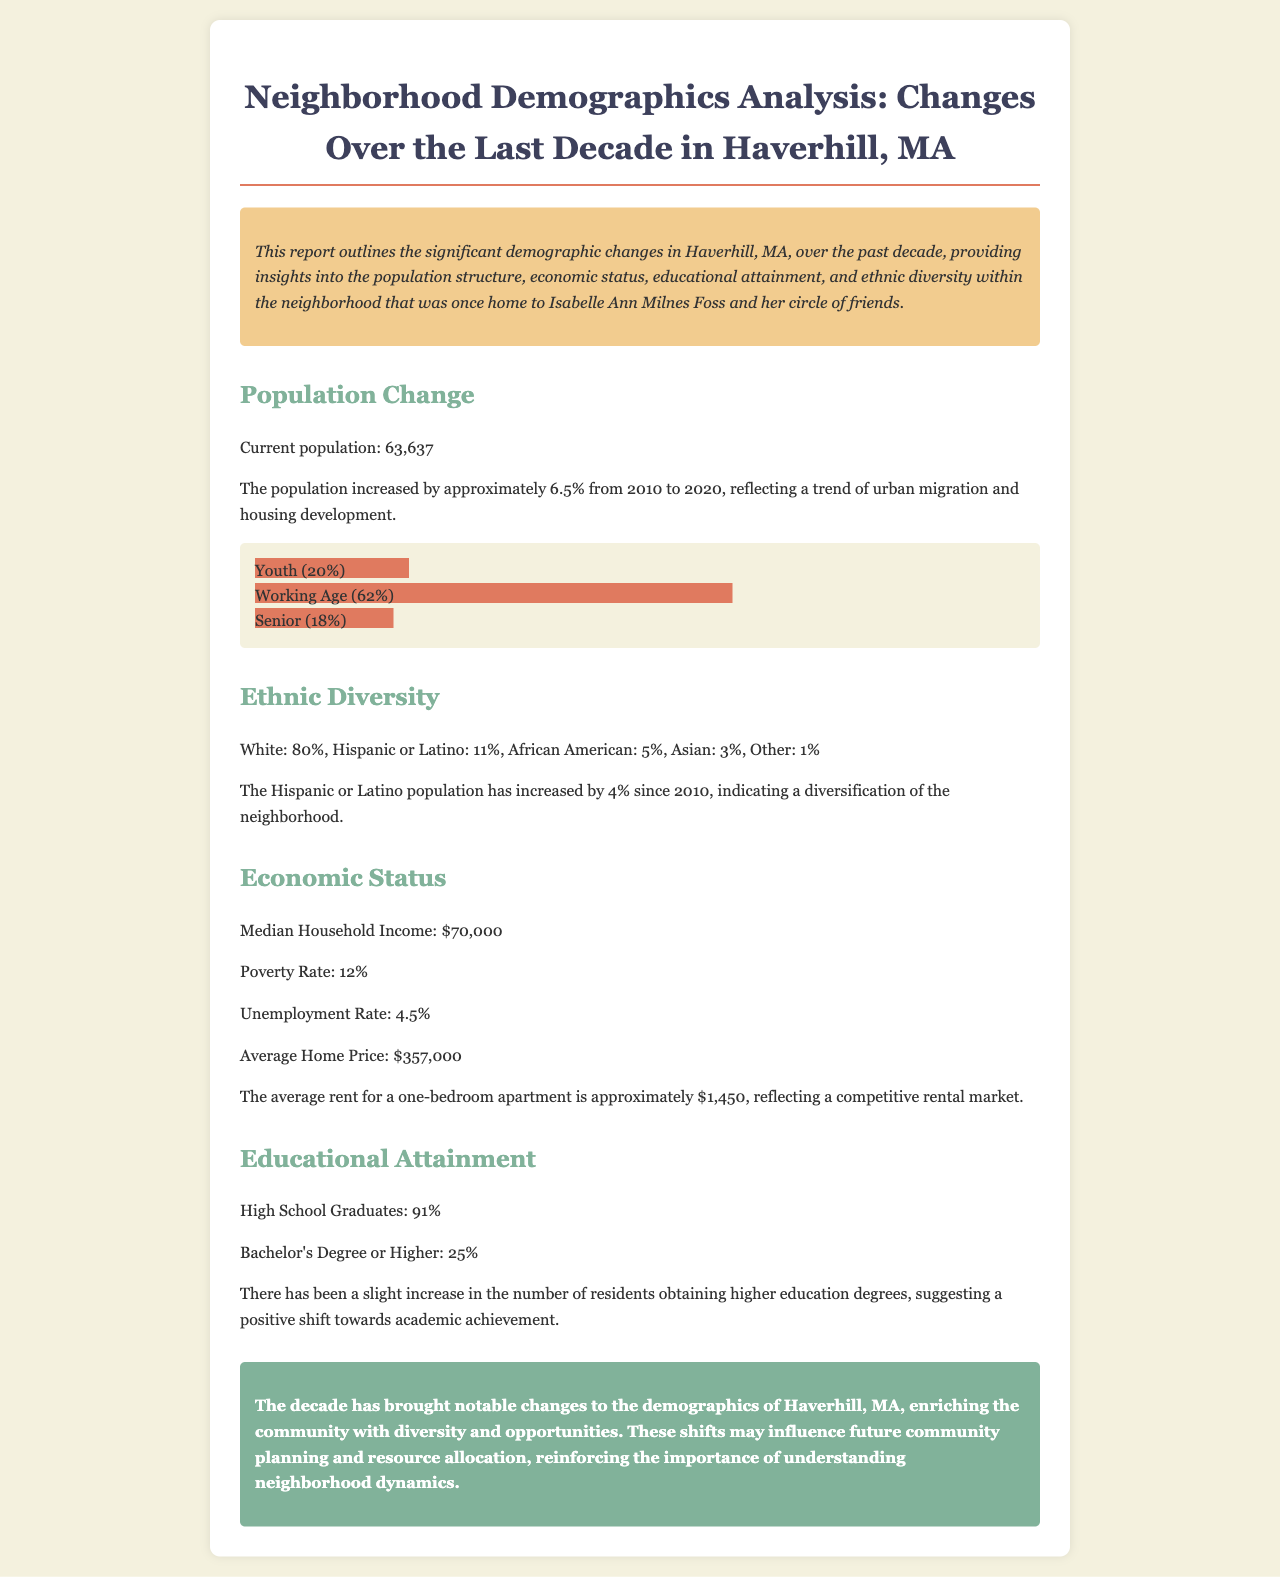What is the current population of Haverhill, MA? The current population is mentioned in the document as 63,637.
Answer: 63,637 By what percentage did the population increase from 2010 to 2020? The document states that the population increased by approximately 6.5% from 2010 to 2020.
Answer: 6.5% What percentage of the population identifies as White? The document specifies that the percentage of the population identifying as White is 80%.
Answer: 80% What is the median household income in Haverhill, MA? According to the economic status section, the median household income is $70,000.
Answer: $70,000 What has been the trend in the Hispanic or Latino population since 2010? The document states that the Hispanic or Latino population has increased by 4% since 2010.
Answer: Increased by 4% What is the unemployment rate mentioned in the report? The unemployment rate is provided in the economic status section as 4.5%.
Answer: 4.5% What percentage of residents have a Bachelor's Degree or higher? The report indicates that 25% of residents have a Bachelor's Degree or higher.
Answer: 25% What significant change has occurred in educational attainment over the decade? The document mentions a slight increase in the number of residents obtaining higher education degrees.
Answer: Slight increase In what ways might the demographic changes influence community planning? The conclusion suggests that understanding neighborhood dynamics will influence future community planning and resource allocation.
Answer: Influence planning and resource allocation 